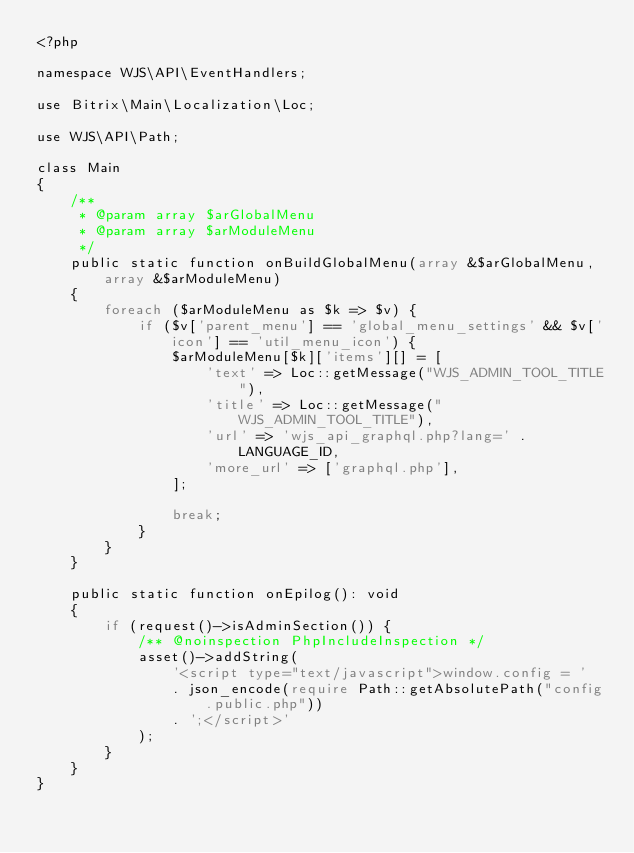<code> <loc_0><loc_0><loc_500><loc_500><_PHP_><?php

namespace WJS\API\EventHandlers;

use Bitrix\Main\Localization\Loc;

use WJS\API\Path;

class Main
{
    /**
     * @param array $arGlobalMenu
     * @param array $arModuleMenu
     */
    public static function onBuildGlobalMenu(array &$arGlobalMenu, array &$arModuleMenu)
    {
        foreach ($arModuleMenu as $k => $v) {
            if ($v['parent_menu'] == 'global_menu_settings' && $v['icon'] == 'util_menu_icon') {
                $arModuleMenu[$k]['items'][] = [
                    'text' => Loc::getMessage("WJS_ADMIN_TOOL_TITLE"),
                    'title' => Loc::getMessage("WJS_ADMIN_TOOL_TITLE"),
                    'url' => 'wjs_api_graphql.php?lang=' . LANGUAGE_ID,
                    'more_url' => ['graphql.php'],
                ];

                break;
            }
        }
    }

    public static function onEpilog(): void
    {
        if (request()->isAdminSection()) {
            /** @noinspection PhpIncludeInspection */
            asset()->addString(
                '<script type="text/javascript">window.config = '
                . json_encode(require Path::getAbsolutePath("config.public.php"))
                . ';</script>'
            );
        }
    }
}
</code> 